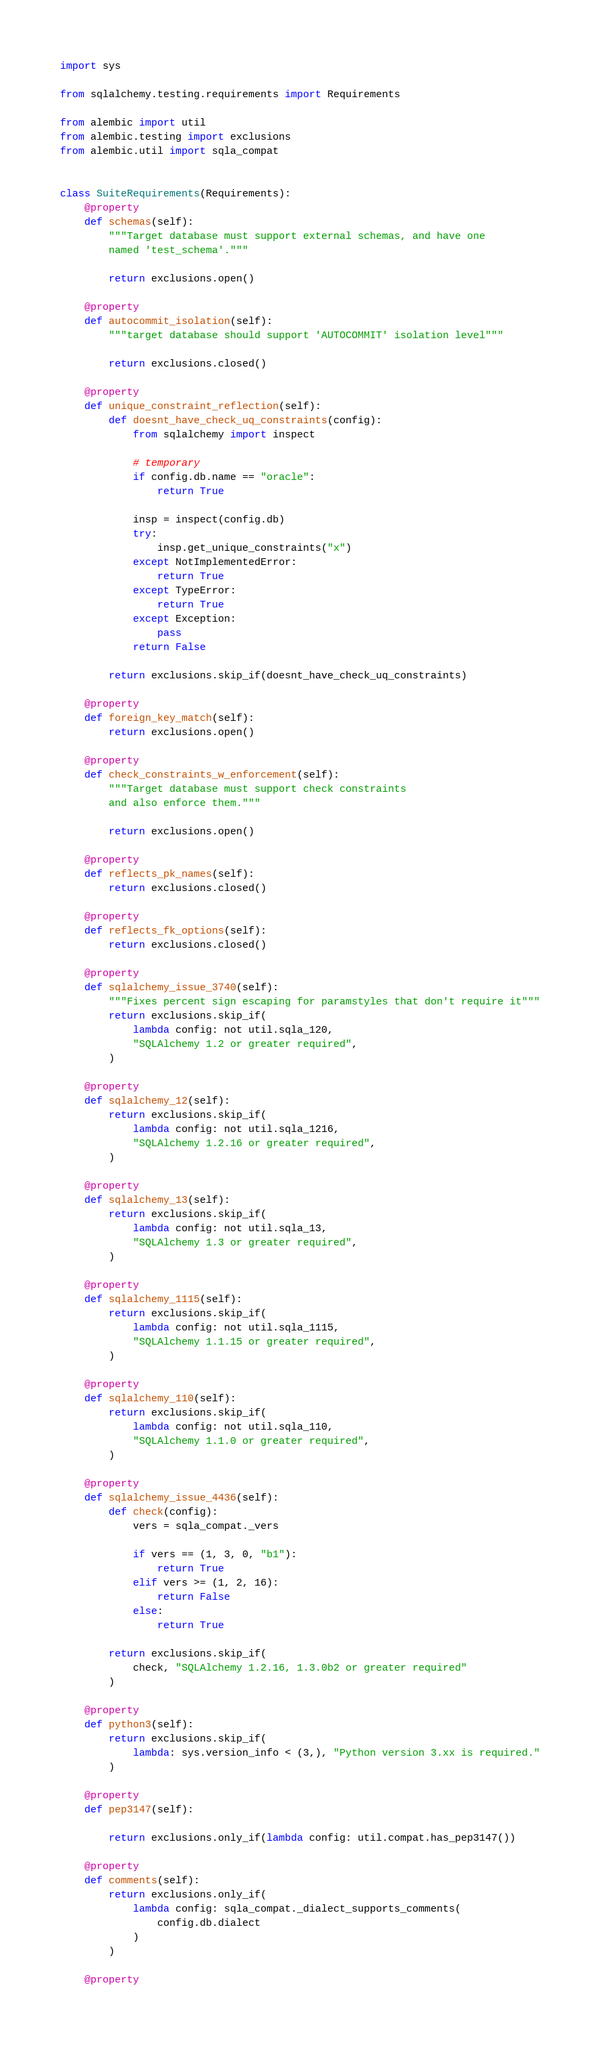<code> <loc_0><loc_0><loc_500><loc_500><_Python_>import sys

from sqlalchemy.testing.requirements import Requirements

from alembic import util
from alembic.testing import exclusions
from alembic.util import sqla_compat


class SuiteRequirements(Requirements):
    @property
    def schemas(self):
        """Target database must support external schemas, and have one
        named 'test_schema'."""

        return exclusions.open()

    @property
    def autocommit_isolation(self):
        """target database should support 'AUTOCOMMIT' isolation level"""

        return exclusions.closed()

    @property
    def unique_constraint_reflection(self):
        def doesnt_have_check_uq_constraints(config):
            from sqlalchemy import inspect

            # temporary
            if config.db.name == "oracle":
                return True

            insp = inspect(config.db)
            try:
                insp.get_unique_constraints("x")
            except NotImplementedError:
                return True
            except TypeError:
                return True
            except Exception:
                pass
            return False

        return exclusions.skip_if(doesnt_have_check_uq_constraints)

    @property
    def foreign_key_match(self):
        return exclusions.open()

    @property
    def check_constraints_w_enforcement(self):
        """Target database must support check constraints
        and also enforce them."""

        return exclusions.open()

    @property
    def reflects_pk_names(self):
        return exclusions.closed()

    @property
    def reflects_fk_options(self):
        return exclusions.closed()

    @property
    def sqlalchemy_issue_3740(self):
        """Fixes percent sign escaping for paramstyles that don't require it"""
        return exclusions.skip_if(
            lambda config: not util.sqla_120,
            "SQLAlchemy 1.2 or greater required",
        )

    @property
    def sqlalchemy_12(self):
        return exclusions.skip_if(
            lambda config: not util.sqla_1216,
            "SQLAlchemy 1.2.16 or greater required",
        )

    @property
    def sqlalchemy_13(self):
        return exclusions.skip_if(
            lambda config: not util.sqla_13,
            "SQLAlchemy 1.3 or greater required",
        )

    @property
    def sqlalchemy_1115(self):
        return exclusions.skip_if(
            lambda config: not util.sqla_1115,
            "SQLAlchemy 1.1.15 or greater required",
        )

    @property
    def sqlalchemy_110(self):
        return exclusions.skip_if(
            lambda config: not util.sqla_110,
            "SQLAlchemy 1.1.0 or greater required",
        )

    @property
    def sqlalchemy_issue_4436(self):
        def check(config):
            vers = sqla_compat._vers

            if vers == (1, 3, 0, "b1"):
                return True
            elif vers >= (1, 2, 16):
                return False
            else:
                return True

        return exclusions.skip_if(
            check, "SQLAlchemy 1.2.16, 1.3.0b2 or greater required"
        )

    @property
    def python3(self):
        return exclusions.skip_if(
            lambda: sys.version_info < (3,), "Python version 3.xx is required."
        )

    @property
    def pep3147(self):

        return exclusions.only_if(lambda config: util.compat.has_pep3147())

    @property
    def comments(self):
        return exclusions.only_if(
            lambda config: sqla_compat._dialect_supports_comments(
                config.db.dialect
            )
        )

    @property</code> 